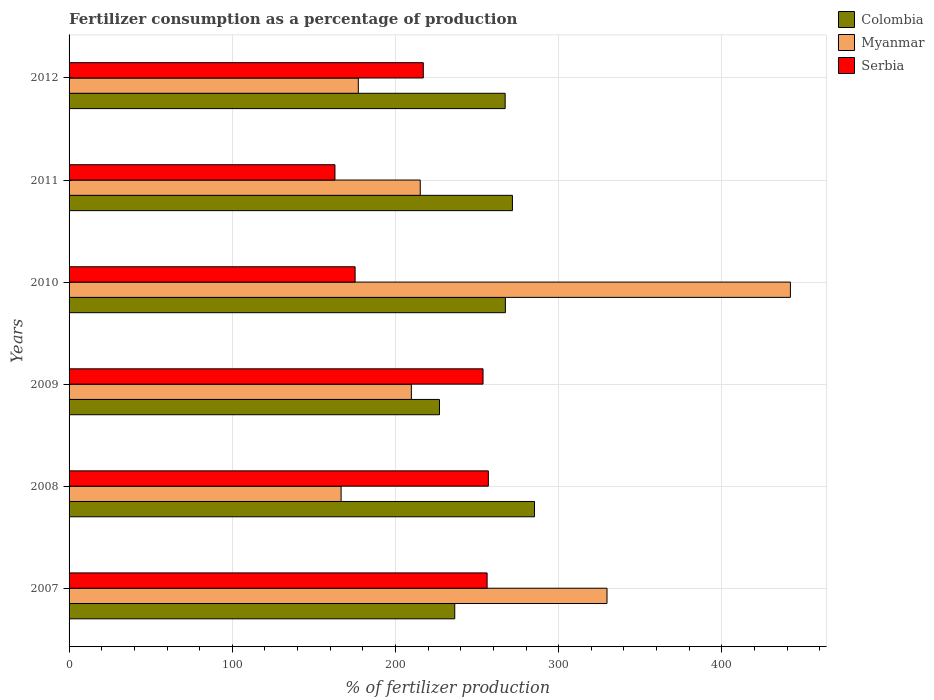How many different coloured bars are there?
Your response must be concise. 3. How many groups of bars are there?
Your answer should be very brief. 6. Are the number of bars on each tick of the Y-axis equal?
Provide a succinct answer. Yes. How many bars are there on the 2nd tick from the top?
Offer a terse response. 3. How many bars are there on the 4th tick from the bottom?
Your response must be concise. 3. What is the label of the 2nd group of bars from the top?
Your response must be concise. 2011. In how many cases, is the number of bars for a given year not equal to the number of legend labels?
Ensure brevity in your answer.  0. What is the percentage of fertilizers consumed in Myanmar in 2010?
Offer a very short reply. 441.98. Across all years, what is the maximum percentage of fertilizers consumed in Myanmar?
Offer a terse response. 441.98. Across all years, what is the minimum percentage of fertilizers consumed in Serbia?
Give a very brief answer. 162.92. In which year was the percentage of fertilizers consumed in Myanmar minimum?
Your answer should be compact. 2008. What is the total percentage of fertilizers consumed in Myanmar in the graph?
Your answer should be very brief. 1540.39. What is the difference between the percentage of fertilizers consumed in Myanmar in 2007 and that in 2012?
Ensure brevity in your answer.  152.39. What is the difference between the percentage of fertilizers consumed in Colombia in 2010 and the percentage of fertilizers consumed in Serbia in 2012?
Offer a very short reply. 50.3. What is the average percentage of fertilizers consumed in Serbia per year?
Provide a succinct answer. 220.32. In the year 2008, what is the difference between the percentage of fertilizers consumed in Colombia and percentage of fertilizers consumed in Myanmar?
Your answer should be very brief. 118.51. In how many years, is the percentage of fertilizers consumed in Serbia greater than 160 %?
Provide a short and direct response. 6. What is the ratio of the percentage of fertilizers consumed in Serbia in 2009 to that in 2011?
Your response must be concise. 1.56. What is the difference between the highest and the second highest percentage of fertilizers consumed in Serbia?
Provide a succinct answer. 0.76. What is the difference between the highest and the lowest percentage of fertilizers consumed in Serbia?
Keep it short and to the point. 93.98. In how many years, is the percentage of fertilizers consumed in Myanmar greater than the average percentage of fertilizers consumed in Myanmar taken over all years?
Your response must be concise. 2. What does the 1st bar from the top in 2009 represents?
Ensure brevity in your answer.  Serbia. What does the 3rd bar from the bottom in 2011 represents?
Give a very brief answer. Serbia. Is it the case that in every year, the sum of the percentage of fertilizers consumed in Myanmar and percentage of fertilizers consumed in Colombia is greater than the percentage of fertilizers consumed in Serbia?
Keep it short and to the point. Yes. How many years are there in the graph?
Your response must be concise. 6. Are the values on the major ticks of X-axis written in scientific E-notation?
Your response must be concise. No. Does the graph contain any zero values?
Ensure brevity in your answer.  No. Does the graph contain grids?
Make the answer very short. Yes. Where does the legend appear in the graph?
Your answer should be very brief. Top right. How many legend labels are there?
Offer a terse response. 3. How are the legend labels stacked?
Provide a short and direct response. Vertical. What is the title of the graph?
Provide a short and direct response. Fertilizer consumption as a percentage of production. What is the label or title of the X-axis?
Keep it short and to the point. % of fertilizer production. What is the % of fertilizer production of Colombia in 2007?
Your response must be concise. 236.31. What is the % of fertilizer production of Myanmar in 2007?
Offer a terse response. 329.61. What is the % of fertilizer production in Serbia in 2007?
Your answer should be compact. 256.14. What is the % of fertilizer production of Colombia in 2008?
Give a very brief answer. 285.19. What is the % of fertilizer production of Myanmar in 2008?
Your answer should be compact. 166.68. What is the % of fertilizer production of Serbia in 2008?
Offer a terse response. 256.9. What is the % of fertilizer production in Colombia in 2009?
Offer a terse response. 226.96. What is the % of fertilizer production of Myanmar in 2009?
Offer a terse response. 209.73. What is the % of fertilizer production in Serbia in 2009?
Your answer should be very brief. 253.64. What is the % of fertilizer production in Colombia in 2010?
Your answer should be compact. 267.34. What is the % of fertilizer production in Myanmar in 2010?
Ensure brevity in your answer.  441.98. What is the % of fertilizer production in Serbia in 2010?
Make the answer very short. 175.26. What is the % of fertilizer production of Colombia in 2011?
Your answer should be very brief. 271.65. What is the % of fertilizer production of Myanmar in 2011?
Ensure brevity in your answer.  215.18. What is the % of fertilizer production in Serbia in 2011?
Give a very brief answer. 162.92. What is the % of fertilizer production of Colombia in 2012?
Your answer should be very brief. 267.2. What is the % of fertilizer production in Myanmar in 2012?
Your answer should be compact. 177.22. What is the % of fertilizer production of Serbia in 2012?
Your answer should be very brief. 217.05. Across all years, what is the maximum % of fertilizer production of Colombia?
Provide a succinct answer. 285.19. Across all years, what is the maximum % of fertilizer production of Myanmar?
Make the answer very short. 441.98. Across all years, what is the maximum % of fertilizer production in Serbia?
Provide a short and direct response. 256.9. Across all years, what is the minimum % of fertilizer production of Colombia?
Offer a terse response. 226.96. Across all years, what is the minimum % of fertilizer production of Myanmar?
Your answer should be compact. 166.68. Across all years, what is the minimum % of fertilizer production in Serbia?
Your response must be concise. 162.92. What is the total % of fertilizer production in Colombia in the graph?
Provide a succinct answer. 1554.66. What is the total % of fertilizer production in Myanmar in the graph?
Make the answer very short. 1540.39. What is the total % of fertilizer production in Serbia in the graph?
Offer a very short reply. 1321.9. What is the difference between the % of fertilizer production in Colombia in 2007 and that in 2008?
Offer a terse response. -48.88. What is the difference between the % of fertilizer production in Myanmar in 2007 and that in 2008?
Make the answer very short. 162.93. What is the difference between the % of fertilizer production of Serbia in 2007 and that in 2008?
Your answer should be compact. -0.76. What is the difference between the % of fertilizer production in Colombia in 2007 and that in 2009?
Give a very brief answer. 9.35. What is the difference between the % of fertilizer production of Myanmar in 2007 and that in 2009?
Offer a terse response. 119.89. What is the difference between the % of fertilizer production of Serbia in 2007 and that in 2009?
Offer a very short reply. 2.49. What is the difference between the % of fertilizer production of Colombia in 2007 and that in 2010?
Offer a very short reply. -31.03. What is the difference between the % of fertilizer production of Myanmar in 2007 and that in 2010?
Your response must be concise. -112.36. What is the difference between the % of fertilizer production of Serbia in 2007 and that in 2010?
Provide a succinct answer. 80.88. What is the difference between the % of fertilizer production in Colombia in 2007 and that in 2011?
Your answer should be compact. -35.34. What is the difference between the % of fertilizer production in Myanmar in 2007 and that in 2011?
Ensure brevity in your answer.  114.44. What is the difference between the % of fertilizer production in Serbia in 2007 and that in 2011?
Provide a succinct answer. 93.22. What is the difference between the % of fertilizer production of Colombia in 2007 and that in 2012?
Offer a terse response. -30.89. What is the difference between the % of fertilizer production of Myanmar in 2007 and that in 2012?
Offer a very short reply. 152.39. What is the difference between the % of fertilizer production of Serbia in 2007 and that in 2012?
Ensure brevity in your answer.  39.09. What is the difference between the % of fertilizer production in Colombia in 2008 and that in 2009?
Provide a short and direct response. 58.23. What is the difference between the % of fertilizer production in Myanmar in 2008 and that in 2009?
Keep it short and to the point. -43.05. What is the difference between the % of fertilizer production of Serbia in 2008 and that in 2009?
Ensure brevity in your answer.  3.25. What is the difference between the % of fertilizer production of Colombia in 2008 and that in 2010?
Provide a succinct answer. 17.85. What is the difference between the % of fertilizer production in Myanmar in 2008 and that in 2010?
Ensure brevity in your answer.  -275.3. What is the difference between the % of fertilizer production of Serbia in 2008 and that in 2010?
Your answer should be compact. 81.64. What is the difference between the % of fertilizer production in Colombia in 2008 and that in 2011?
Provide a short and direct response. 13.54. What is the difference between the % of fertilizer production of Myanmar in 2008 and that in 2011?
Offer a very short reply. -48.5. What is the difference between the % of fertilizer production in Serbia in 2008 and that in 2011?
Ensure brevity in your answer.  93.98. What is the difference between the % of fertilizer production in Colombia in 2008 and that in 2012?
Offer a very short reply. 17.99. What is the difference between the % of fertilizer production in Myanmar in 2008 and that in 2012?
Offer a very short reply. -10.54. What is the difference between the % of fertilizer production of Serbia in 2008 and that in 2012?
Your answer should be very brief. 39.85. What is the difference between the % of fertilizer production in Colombia in 2009 and that in 2010?
Make the answer very short. -40.38. What is the difference between the % of fertilizer production in Myanmar in 2009 and that in 2010?
Keep it short and to the point. -232.25. What is the difference between the % of fertilizer production in Serbia in 2009 and that in 2010?
Keep it short and to the point. 78.39. What is the difference between the % of fertilizer production in Colombia in 2009 and that in 2011?
Ensure brevity in your answer.  -44.69. What is the difference between the % of fertilizer production of Myanmar in 2009 and that in 2011?
Provide a succinct answer. -5.45. What is the difference between the % of fertilizer production in Serbia in 2009 and that in 2011?
Provide a short and direct response. 90.73. What is the difference between the % of fertilizer production in Colombia in 2009 and that in 2012?
Offer a very short reply. -40.24. What is the difference between the % of fertilizer production in Myanmar in 2009 and that in 2012?
Offer a terse response. 32.51. What is the difference between the % of fertilizer production in Serbia in 2009 and that in 2012?
Make the answer very short. 36.6. What is the difference between the % of fertilizer production in Colombia in 2010 and that in 2011?
Provide a short and direct response. -4.31. What is the difference between the % of fertilizer production in Myanmar in 2010 and that in 2011?
Provide a succinct answer. 226.8. What is the difference between the % of fertilizer production in Serbia in 2010 and that in 2011?
Keep it short and to the point. 12.34. What is the difference between the % of fertilizer production in Colombia in 2010 and that in 2012?
Give a very brief answer. 0.15. What is the difference between the % of fertilizer production of Myanmar in 2010 and that in 2012?
Offer a very short reply. 264.76. What is the difference between the % of fertilizer production of Serbia in 2010 and that in 2012?
Provide a succinct answer. -41.79. What is the difference between the % of fertilizer production of Colombia in 2011 and that in 2012?
Provide a succinct answer. 4.46. What is the difference between the % of fertilizer production of Myanmar in 2011 and that in 2012?
Offer a very short reply. 37.96. What is the difference between the % of fertilizer production of Serbia in 2011 and that in 2012?
Offer a terse response. -54.13. What is the difference between the % of fertilizer production of Colombia in 2007 and the % of fertilizer production of Myanmar in 2008?
Ensure brevity in your answer.  69.63. What is the difference between the % of fertilizer production of Colombia in 2007 and the % of fertilizer production of Serbia in 2008?
Offer a terse response. -20.59. What is the difference between the % of fertilizer production in Myanmar in 2007 and the % of fertilizer production in Serbia in 2008?
Give a very brief answer. 72.72. What is the difference between the % of fertilizer production of Colombia in 2007 and the % of fertilizer production of Myanmar in 2009?
Make the answer very short. 26.58. What is the difference between the % of fertilizer production of Colombia in 2007 and the % of fertilizer production of Serbia in 2009?
Keep it short and to the point. -17.33. What is the difference between the % of fertilizer production in Myanmar in 2007 and the % of fertilizer production in Serbia in 2009?
Your response must be concise. 75.97. What is the difference between the % of fertilizer production of Colombia in 2007 and the % of fertilizer production of Myanmar in 2010?
Your answer should be very brief. -205.67. What is the difference between the % of fertilizer production of Colombia in 2007 and the % of fertilizer production of Serbia in 2010?
Give a very brief answer. 61.05. What is the difference between the % of fertilizer production in Myanmar in 2007 and the % of fertilizer production in Serbia in 2010?
Keep it short and to the point. 154.35. What is the difference between the % of fertilizer production of Colombia in 2007 and the % of fertilizer production of Myanmar in 2011?
Your answer should be compact. 21.13. What is the difference between the % of fertilizer production in Colombia in 2007 and the % of fertilizer production in Serbia in 2011?
Ensure brevity in your answer.  73.39. What is the difference between the % of fertilizer production of Myanmar in 2007 and the % of fertilizer production of Serbia in 2011?
Keep it short and to the point. 166.7. What is the difference between the % of fertilizer production in Colombia in 2007 and the % of fertilizer production in Myanmar in 2012?
Your answer should be very brief. 59.09. What is the difference between the % of fertilizer production in Colombia in 2007 and the % of fertilizer production in Serbia in 2012?
Ensure brevity in your answer.  19.26. What is the difference between the % of fertilizer production in Myanmar in 2007 and the % of fertilizer production in Serbia in 2012?
Keep it short and to the point. 112.57. What is the difference between the % of fertilizer production in Colombia in 2008 and the % of fertilizer production in Myanmar in 2009?
Provide a succinct answer. 75.46. What is the difference between the % of fertilizer production in Colombia in 2008 and the % of fertilizer production in Serbia in 2009?
Your answer should be compact. 31.55. What is the difference between the % of fertilizer production of Myanmar in 2008 and the % of fertilizer production of Serbia in 2009?
Make the answer very short. -86.97. What is the difference between the % of fertilizer production of Colombia in 2008 and the % of fertilizer production of Myanmar in 2010?
Your answer should be compact. -156.79. What is the difference between the % of fertilizer production in Colombia in 2008 and the % of fertilizer production in Serbia in 2010?
Your answer should be compact. 109.93. What is the difference between the % of fertilizer production in Myanmar in 2008 and the % of fertilizer production in Serbia in 2010?
Your answer should be very brief. -8.58. What is the difference between the % of fertilizer production in Colombia in 2008 and the % of fertilizer production in Myanmar in 2011?
Make the answer very short. 70.01. What is the difference between the % of fertilizer production in Colombia in 2008 and the % of fertilizer production in Serbia in 2011?
Provide a short and direct response. 122.28. What is the difference between the % of fertilizer production of Myanmar in 2008 and the % of fertilizer production of Serbia in 2011?
Offer a terse response. 3.76. What is the difference between the % of fertilizer production in Colombia in 2008 and the % of fertilizer production in Myanmar in 2012?
Offer a terse response. 107.97. What is the difference between the % of fertilizer production of Colombia in 2008 and the % of fertilizer production of Serbia in 2012?
Give a very brief answer. 68.15. What is the difference between the % of fertilizer production in Myanmar in 2008 and the % of fertilizer production in Serbia in 2012?
Keep it short and to the point. -50.37. What is the difference between the % of fertilizer production in Colombia in 2009 and the % of fertilizer production in Myanmar in 2010?
Offer a very short reply. -215.01. What is the difference between the % of fertilizer production of Colombia in 2009 and the % of fertilizer production of Serbia in 2010?
Provide a short and direct response. 51.71. What is the difference between the % of fertilizer production of Myanmar in 2009 and the % of fertilizer production of Serbia in 2010?
Offer a terse response. 34.47. What is the difference between the % of fertilizer production in Colombia in 2009 and the % of fertilizer production in Myanmar in 2011?
Keep it short and to the point. 11.79. What is the difference between the % of fertilizer production in Colombia in 2009 and the % of fertilizer production in Serbia in 2011?
Keep it short and to the point. 64.05. What is the difference between the % of fertilizer production of Myanmar in 2009 and the % of fertilizer production of Serbia in 2011?
Keep it short and to the point. 46.81. What is the difference between the % of fertilizer production in Colombia in 2009 and the % of fertilizer production in Myanmar in 2012?
Keep it short and to the point. 49.74. What is the difference between the % of fertilizer production in Colombia in 2009 and the % of fertilizer production in Serbia in 2012?
Give a very brief answer. 9.92. What is the difference between the % of fertilizer production in Myanmar in 2009 and the % of fertilizer production in Serbia in 2012?
Keep it short and to the point. -7.32. What is the difference between the % of fertilizer production in Colombia in 2010 and the % of fertilizer production in Myanmar in 2011?
Your answer should be compact. 52.17. What is the difference between the % of fertilizer production in Colombia in 2010 and the % of fertilizer production in Serbia in 2011?
Give a very brief answer. 104.43. What is the difference between the % of fertilizer production in Myanmar in 2010 and the % of fertilizer production in Serbia in 2011?
Your response must be concise. 279.06. What is the difference between the % of fertilizer production of Colombia in 2010 and the % of fertilizer production of Myanmar in 2012?
Offer a terse response. 90.12. What is the difference between the % of fertilizer production of Colombia in 2010 and the % of fertilizer production of Serbia in 2012?
Offer a very short reply. 50.3. What is the difference between the % of fertilizer production of Myanmar in 2010 and the % of fertilizer production of Serbia in 2012?
Your response must be concise. 224.93. What is the difference between the % of fertilizer production of Colombia in 2011 and the % of fertilizer production of Myanmar in 2012?
Give a very brief answer. 94.43. What is the difference between the % of fertilizer production of Colombia in 2011 and the % of fertilizer production of Serbia in 2012?
Keep it short and to the point. 54.61. What is the difference between the % of fertilizer production in Myanmar in 2011 and the % of fertilizer production in Serbia in 2012?
Your answer should be compact. -1.87. What is the average % of fertilizer production in Colombia per year?
Offer a very short reply. 259.11. What is the average % of fertilizer production of Myanmar per year?
Provide a succinct answer. 256.73. What is the average % of fertilizer production of Serbia per year?
Offer a terse response. 220.32. In the year 2007, what is the difference between the % of fertilizer production in Colombia and % of fertilizer production in Myanmar?
Keep it short and to the point. -93.3. In the year 2007, what is the difference between the % of fertilizer production of Colombia and % of fertilizer production of Serbia?
Provide a short and direct response. -19.83. In the year 2007, what is the difference between the % of fertilizer production in Myanmar and % of fertilizer production in Serbia?
Provide a succinct answer. 73.47. In the year 2008, what is the difference between the % of fertilizer production of Colombia and % of fertilizer production of Myanmar?
Your response must be concise. 118.51. In the year 2008, what is the difference between the % of fertilizer production of Colombia and % of fertilizer production of Serbia?
Provide a short and direct response. 28.29. In the year 2008, what is the difference between the % of fertilizer production of Myanmar and % of fertilizer production of Serbia?
Make the answer very short. -90.22. In the year 2009, what is the difference between the % of fertilizer production in Colombia and % of fertilizer production in Myanmar?
Offer a terse response. 17.24. In the year 2009, what is the difference between the % of fertilizer production in Colombia and % of fertilizer production in Serbia?
Ensure brevity in your answer.  -26.68. In the year 2009, what is the difference between the % of fertilizer production of Myanmar and % of fertilizer production of Serbia?
Give a very brief answer. -43.92. In the year 2010, what is the difference between the % of fertilizer production of Colombia and % of fertilizer production of Myanmar?
Your answer should be very brief. -174.63. In the year 2010, what is the difference between the % of fertilizer production in Colombia and % of fertilizer production in Serbia?
Your answer should be very brief. 92.09. In the year 2010, what is the difference between the % of fertilizer production in Myanmar and % of fertilizer production in Serbia?
Ensure brevity in your answer.  266.72. In the year 2011, what is the difference between the % of fertilizer production of Colombia and % of fertilizer production of Myanmar?
Offer a terse response. 56.48. In the year 2011, what is the difference between the % of fertilizer production of Colombia and % of fertilizer production of Serbia?
Offer a terse response. 108.74. In the year 2011, what is the difference between the % of fertilizer production of Myanmar and % of fertilizer production of Serbia?
Provide a short and direct response. 52.26. In the year 2012, what is the difference between the % of fertilizer production of Colombia and % of fertilizer production of Myanmar?
Give a very brief answer. 89.98. In the year 2012, what is the difference between the % of fertilizer production in Colombia and % of fertilizer production in Serbia?
Keep it short and to the point. 50.15. In the year 2012, what is the difference between the % of fertilizer production in Myanmar and % of fertilizer production in Serbia?
Make the answer very short. -39.82. What is the ratio of the % of fertilizer production of Colombia in 2007 to that in 2008?
Provide a short and direct response. 0.83. What is the ratio of the % of fertilizer production of Myanmar in 2007 to that in 2008?
Provide a short and direct response. 1.98. What is the ratio of the % of fertilizer production of Colombia in 2007 to that in 2009?
Give a very brief answer. 1.04. What is the ratio of the % of fertilizer production of Myanmar in 2007 to that in 2009?
Offer a very short reply. 1.57. What is the ratio of the % of fertilizer production in Serbia in 2007 to that in 2009?
Make the answer very short. 1.01. What is the ratio of the % of fertilizer production in Colombia in 2007 to that in 2010?
Ensure brevity in your answer.  0.88. What is the ratio of the % of fertilizer production of Myanmar in 2007 to that in 2010?
Your response must be concise. 0.75. What is the ratio of the % of fertilizer production of Serbia in 2007 to that in 2010?
Your answer should be very brief. 1.46. What is the ratio of the % of fertilizer production of Colombia in 2007 to that in 2011?
Your answer should be very brief. 0.87. What is the ratio of the % of fertilizer production in Myanmar in 2007 to that in 2011?
Offer a terse response. 1.53. What is the ratio of the % of fertilizer production in Serbia in 2007 to that in 2011?
Provide a short and direct response. 1.57. What is the ratio of the % of fertilizer production in Colombia in 2007 to that in 2012?
Offer a very short reply. 0.88. What is the ratio of the % of fertilizer production in Myanmar in 2007 to that in 2012?
Offer a terse response. 1.86. What is the ratio of the % of fertilizer production in Serbia in 2007 to that in 2012?
Keep it short and to the point. 1.18. What is the ratio of the % of fertilizer production of Colombia in 2008 to that in 2009?
Provide a succinct answer. 1.26. What is the ratio of the % of fertilizer production of Myanmar in 2008 to that in 2009?
Your answer should be very brief. 0.79. What is the ratio of the % of fertilizer production of Serbia in 2008 to that in 2009?
Ensure brevity in your answer.  1.01. What is the ratio of the % of fertilizer production in Colombia in 2008 to that in 2010?
Ensure brevity in your answer.  1.07. What is the ratio of the % of fertilizer production in Myanmar in 2008 to that in 2010?
Your response must be concise. 0.38. What is the ratio of the % of fertilizer production of Serbia in 2008 to that in 2010?
Provide a short and direct response. 1.47. What is the ratio of the % of fertilizer production in Colombia in 2008 to that in 2011?
Offer a terse response. 1.05. What is the ratio of the % of fertilizer production of Myanmar in 2008 to that in 2011?
Your response must be concise. 0.77. What is the ratio of the % of fertilizer production in Serbia in 2008 to that in 2011?
Provide a succinct answer. 1.58. What is the ratio of the % of fertilizer production of Colombia in 2008 to that in 2012?
Your response must be concise. 1.07. What is the ratio of the % of fertilizer production of Myanmar in 2008 to that in 2012?
Ensure brevity in your answer.  0.94. What is the ratio of the % of fertilizer production of Serbia in 2008 to that in 2012?
Provide a short and direct response. 1.18. What is the ratio of the % of fertilizer production in Colombia in 2009 to that in 2010?
Offer a very short reply. 0.85. What is the ratio of the % of fertilizer production in Myanmar in 2009 to that in 2010?
Keep it short and to the point. 0.47. What is the ratio of the % of fertilizer production of Serbia in 2009 to that in 2010?
Offer a very short reply. 1.45. What is the ratio of the % of fertilizer production of Colombia in 2009 to that in 2011?
Offer a very short reply. 0.84. What is the ratio of the % of fertilizer production in Myanmar in 2009 to that in 2011?
Ensure brevity in your answer.  0.97. What is the ratio of the % of fertilizer production of Serbia in 2009 to that in 2011?
Your answer should be compact. 1.56. What is the ratio of the % of fertilizer production of Colombia in 2009 to that in 2012?
Provide a short and direct response. 0.85. What is the ratio of the % of fertilizer production of Myanmar in 2009 to that in 2012?
Offer a terse response. 1.18. What is the ratio of the % of fertilizer production of Serbia in 2009 to that in 2012?
Provide a short and direct response. 1.17. What is the ratio of the % of fertilizer production in Colombia in 2010 to that in 2011?
Keep it short and to the point. 0.98. What is the ratio of the % of fertilizer production in Myanmar in 2010 to that in 2011?
Your answer should be very brief. 2.05. What is the ratio of the % of fertilizer production of Serbia in 2010 to that in 2011?
Keep it short and to the point. 1.08. What is the ratio of the % of fertilizer production in Colombia in 2010 to that in 2012?
Your response must be concise. 1. What is the ratio of the % of fertilizer production in Myanmar in 2010 to that in 2012?
Provide a succinct answer. 2.49. What is the ratio of the % of fertilizer production of Serbia in 2010 to that in 2012?
Your answer should be very brief. 0.81. What is the ratio of the % of fertilizer production of Colombia in 2011 to that in 2012?
Offer a very short reply. 1.02. What is the ratio of the % of fertilizer production in Myanmar in 2011 to that in 2012?
Your response must be concise. 1.21. What is the ratio of the % of fertilizer production of Serbia in 2011 to that in 2012?
Your response must be concise. 0.75. What is the difference between the highest and the second highest % of fertilizer production in Colombia?
Provide a succinct answer. 13.54. What is the difference between the highest and the second highest % of fertilizer production in Myanmar?
Your response must be concise. 112.36. What is the difference between the highest and the second highest % of fertilizer production in Serbia?
Offer a terse response. 0.76. What is the difference between the highest and the lowest % of fertilizer production in Colombia?
Offer a terse response. 58.23. What is the difference between the highest and the lowest % of fertilizer production in Myanmar?
Give a very brief answer. 275.3. What is the difference between the highest and the lowest % of fertilizer production of Serbia?
Your answer should be very brief. 93.98. 